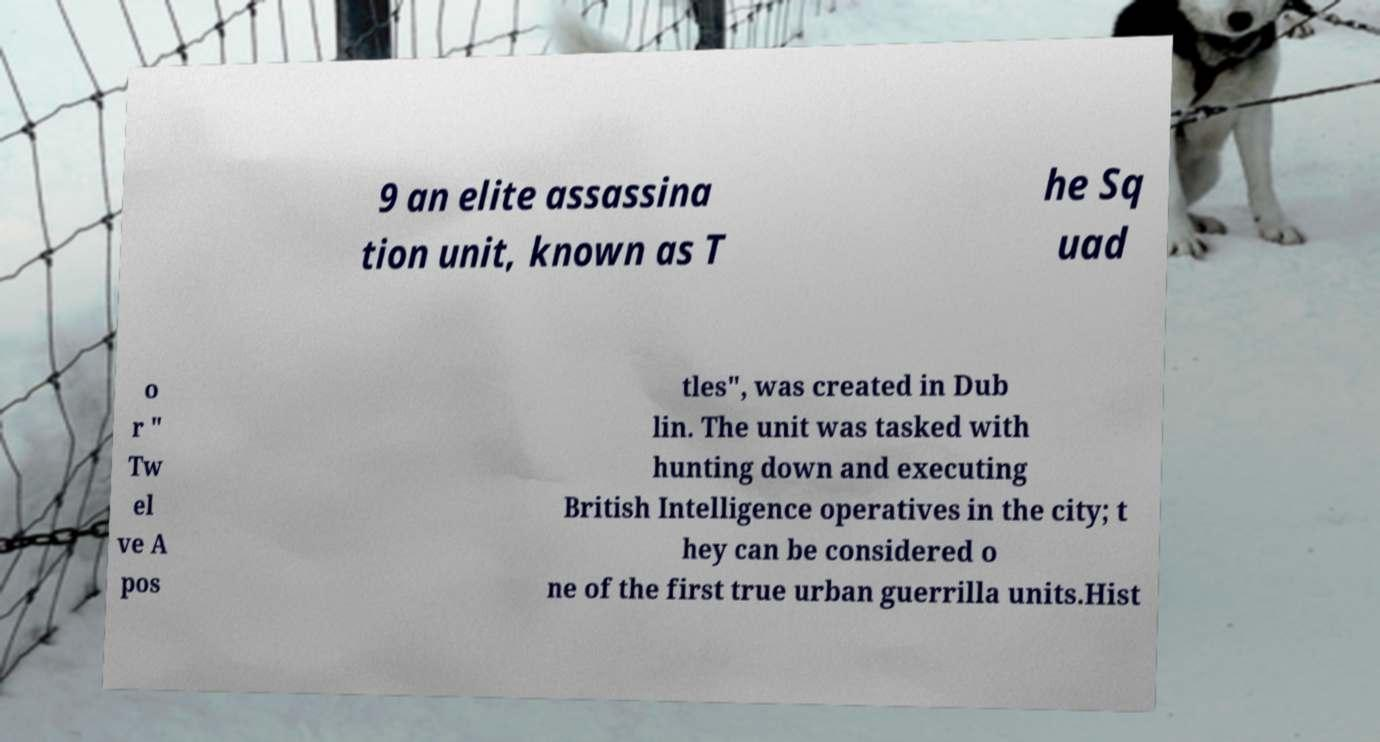Could you extract and type out the text from this image? 9 an elite assassina tion unit, known as T he Sq uad o r " Tw el ve A pos tles", was created in Dub lin. The unit was tasked with hunting down and executing British Intelligence operatives in the city; t hey can be considered o ne of the first true urban guerrilla units.Hist 